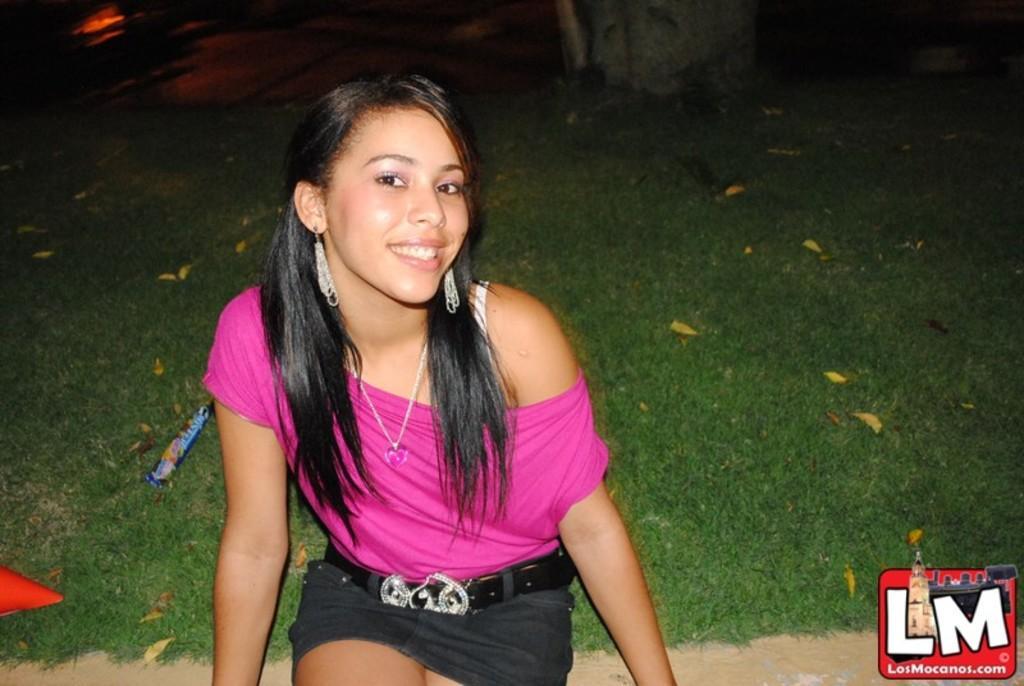How would you summarize this image in a sentence or two? In this image, we can see a girl sitting. We can also see the ground covered with grass, leaves and some objects. We can see a watermark on the right at the bottom corner. 